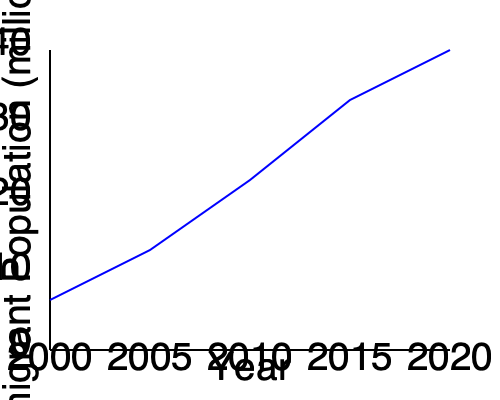Analyze the line graph depicting the change in immigrant population from 2000 to 2020. Calculate the average rate of increase in the immigrant population per year over this 20-year period, expressed in millions per year. To calculate the average rate of increase in the immigrant population per year:

1. Determine the total change in population:
   - Initial population (2000): approximately 10 million
   - Final population (2020): approximately 35 million
   - Total change: $35 - 10 = 25$ million

2. Calculate the time period:
   - From 2000 to 2020: 20 years

3. Use the formula for average rate of change:
   $\text{Average rate} = \frac{\text{Total change}}{\text{Time period}}$

4. Plug in the values:
   $\text{Average rate} = \frac{25 \text{ million}}{20 \text{ years}}$

5. Perform the division:
   $\text{Average rate} = 1.25 \text{ million per year}$

Therefore, the average rate of increase in the immigrant population over the 20-year period is 1.25 million per year.
Answer: 1.25 million per year 